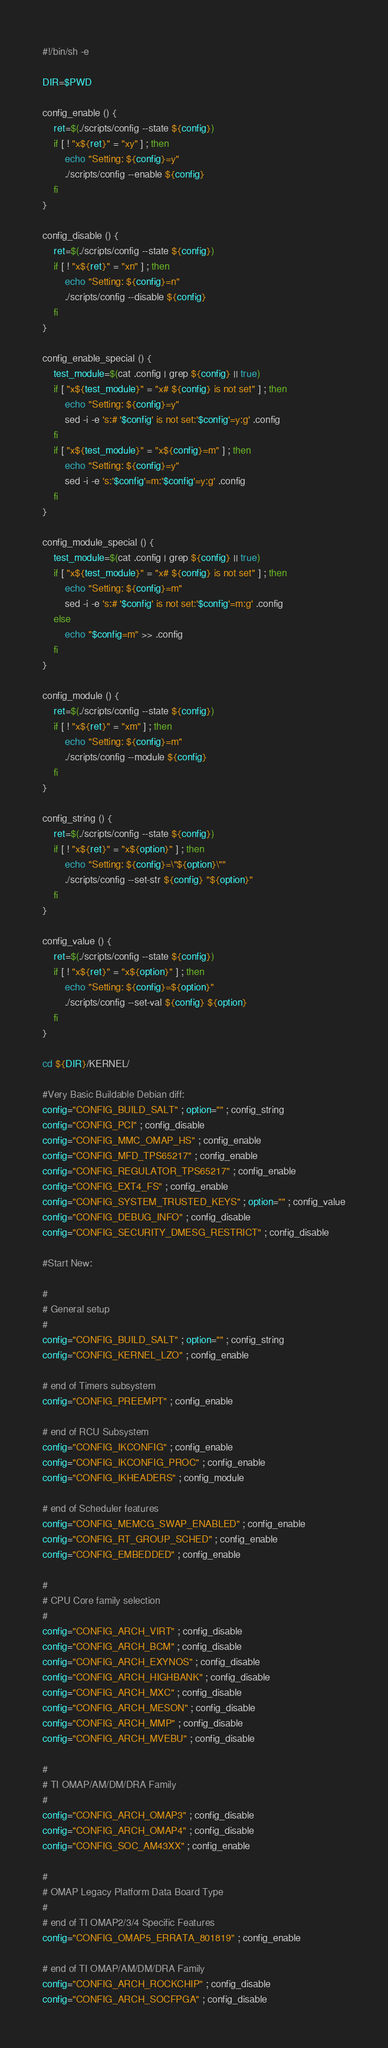<code> <loc_0><loc_0><loc_500><loc_500><_Bash_>#!/bin/sh -e

DIR=$PWD

config_enable () {
	ret=$(./scripts/config --state ${config})
	if [ ! "x${ret}" = "xy" ] ; then
		echo "Setting: ${config}=y"
		./scripts/config --enable ${config}
	fi
}

config_disable () {
	ret=$(./scripts/config --state ${config})
	if [ ! "x${ret}" = "xn" ] ; then
		echo "Setting: ${config}=n"
		./scripts/config --disable ${config}
	fi
}

config_enable_special () {
	test_module=$(cat .config | grep ${config} || true)
	if [ "x${test_module}" = "x# ${config} is not set" ] ; then
		echo "Setting: ${config}=y"
		sed -i -e 's:# '$config' is not set:'$config'=y:g' .config
	fi
	if [ "x${test_module}" = "x${config}=m" ] ; then
		echo "Setting: ${config}=y"
		sed -i -e 's:'$config'=m:'$config'=y:g' .config
	fi
}

config_module_special () {
	test_module=$(cat .config | grep ${config} || true)
	if [ "x${test_module}" = "x# ${config} is not set" ] ; then
		echo "Setting: ${config}=m"
		sed -i -e 's:# '$config' is not set:'$config'=m:g' .config
	else
		echo "$config=m" >> .config
	fi
}

config_module () {
	ret=$(./scripts/config --state ${config})
	if [ ! "x${ret}" = "xm" ] ; then
		echo "Setting: ${config}=m"
		./scripts/config --module ${config}
	fi
}

config_string () {
	ret=$(./scripts/config --state ${config})
	if [ ! "x${ret}" = "x${option}" ] ; then
		echo "Setting: ${config}=\"${option}\""
		./scripts/config --set-str ${config} "${option}"
	fi
}

config_value () {
	ret=$(./scripts/config --state ${config})
	if [ ! "x${ret}" = "x${option}" ] ; then
		echo "Setting: ${config}=${option}"
		./scripts/config --set-val ${config} ${option}
	fi
}

cd ${DIR}/KERNEL/

#Very Basic Buildable Debian diff:
config="CONFIG_BUILD_SALT" ; option="" ; config_string
config="CONFIG_PCI" ; config_disable
config="CONFIG_MMC_OMAP_HS" ; config_enable
config="CONFIG_MFD_TPS65217" ; config_enable
config="CONFIG_REGULATOR_TPS65217" ; config_enable
config="CONFIG_EXT4_FS" ; config_enable
config="CONFIG_SYSTEM_TRUSTED_KEYS" ; option="" ; config_value
config="CONFIG_DEBUG_INFO" ; config_disable
config="CONFIG_SECURITY_DMESG_RESTRICT" ; config_disable

#Start New:

#
# General setup
#
config="CONFIG_BUILD_SALT" ; option="" ; config_string
config="CONFIG_KERNEL_LZO" ; config_enable

# end of Timers subsystem
config="CONFIG_PREEMPT" ; config_enable

# end of RCU Subsystem
config="CONFIG_IKCONFIG" ; config_enable
config="CONFIG_IKCONFIG_PROC" ; config_enable
config="CONFIG_IKHEADERS" ; config_module

# end of Scheduler features
config="CONFIG_MEMCG_SWAP_ENABLED" ; config_enable
config="CONFIG_RT_GROUP_SCHED" ; config_enable
config="CONFIG_EMBEDDED" ; config_enable

#
# CPU Core family selection
#
config="CONFIG_ARCH_VIRT" ; config_disable
config="CONFIG_ARCH_BCM" ; config_disable
config="CONFIG_ARCH_EXYNOS" ; config_disable
config="CONFIG_ARCH_HIGHBANK" ; config_disable
config="CONFIG_ARCH_MXC" ; config_disable
config="CONFIG_ARCH_MESON" ; config_disable
config="CONFIG_ARCH_MMP" ; config_disable
config="CONFIG_ARCH_MVEBU" ; config_disable

#
# TI OMAP/AM/DM/DRA Family
#
config="CONFIG_ARCH_OMAP3" ; config_disable
config="CONFIG_ARCH_OMAP4" ; config_disable
config="CONFIG_SOC_AM43XX" ; config_enable

#
# OMAP Legacy Platform Data Board Type
#
# end of TI OMAP2/3/4 Specific Features
config="CONFIG_OMAP5_ERRATA_801819" ; config_enable

# end of TI OMAP/AM/DM/DRA Family
config="CONFIG_ARCH_ROCKCHIP" ; config_disable
config="CONFIG_ARCH_SOCFPGA" ; config_disable</code> 